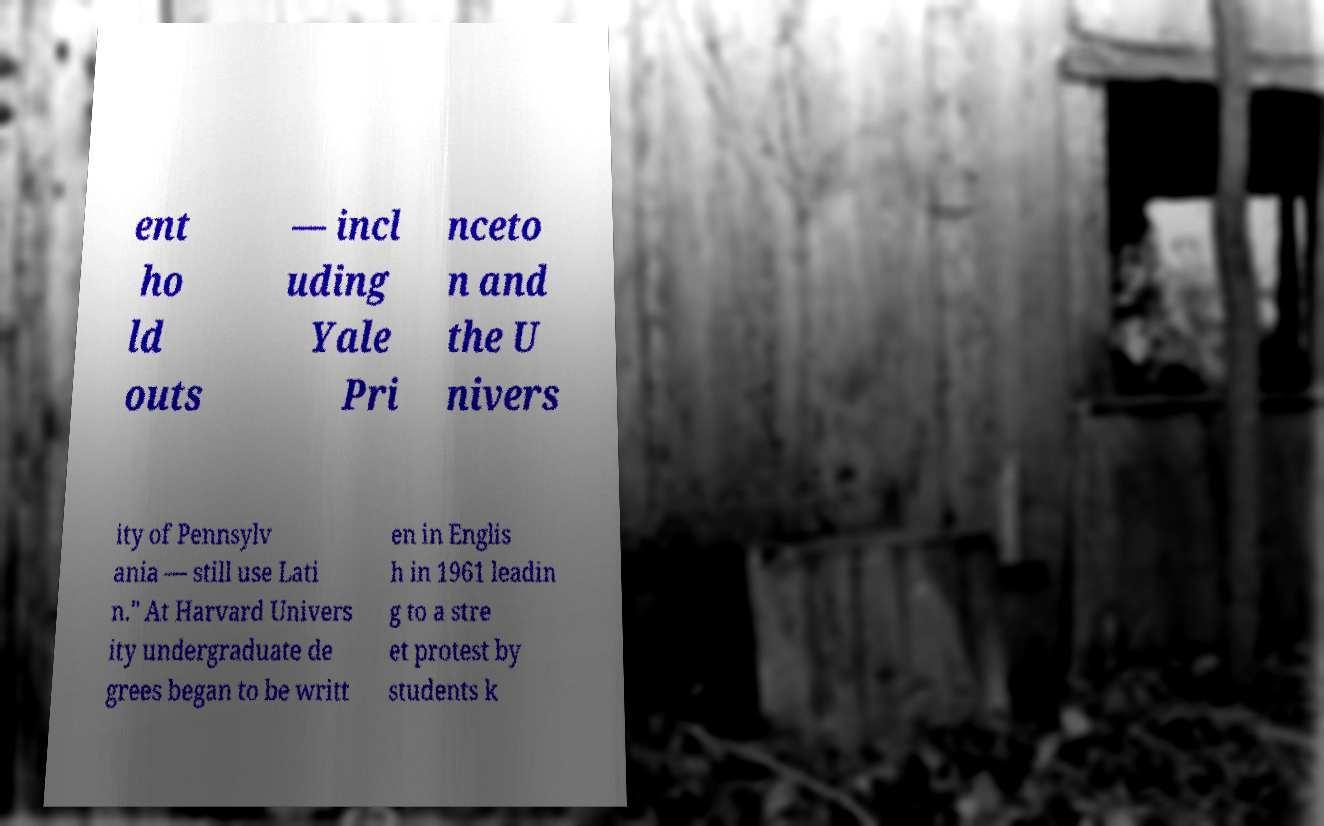Can you accurately transcribe the text from the provided image for me? ent ho ld outs — incl uding Yale Pri nceto n and the U nivers ity of Pennsylv ania — still use Lati n." At Harvard Univers ity undergraduate de grees began to be writt en in Englis h in 1961 leadin g to a stre et protest by students k 